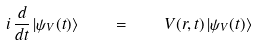<formula> <loc_0><loc_0><loc_500><loc_500>i \, \frac { d } { d t } \, | \psi _ { V } ( t ) \rangle \quad = \quad V ( { r } , t ) \, | \psi _ { V } ( t ) \rangle</formula> 